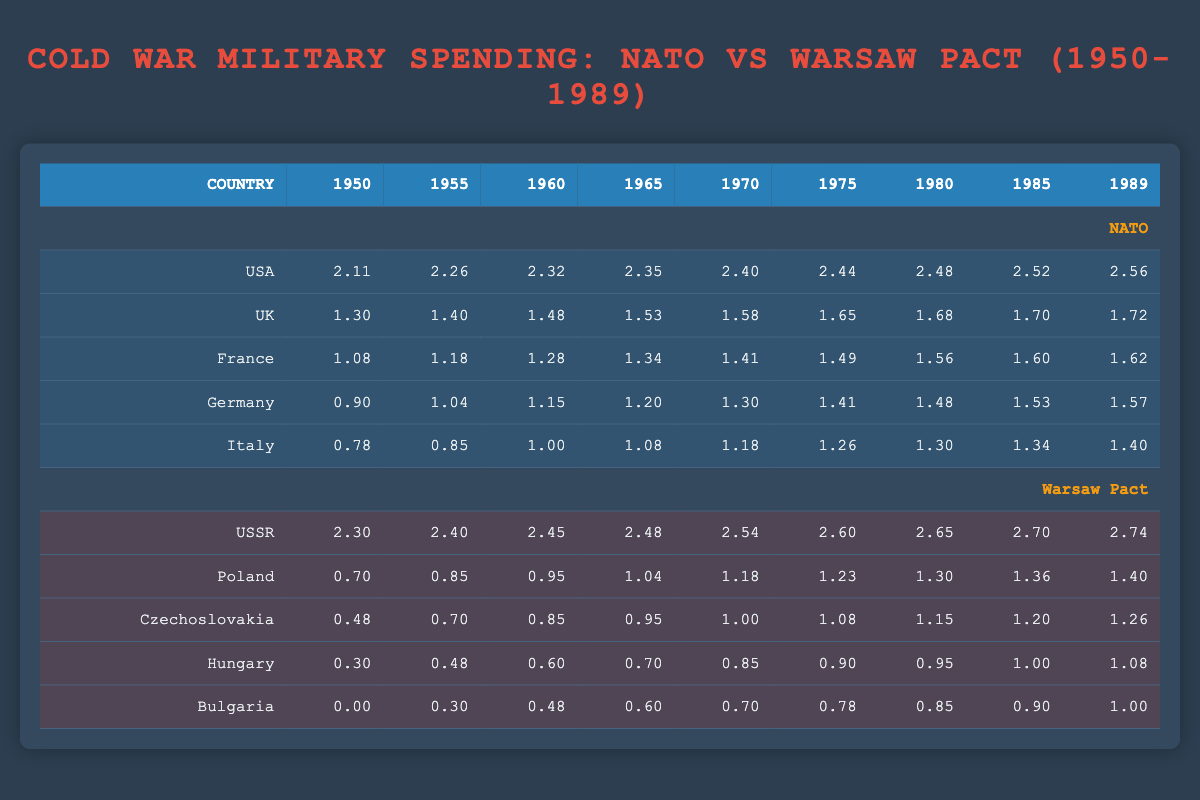What was the military spending of the USA in 1985? The table shows that the military spending of the USA in 1985 is 330.
Answer: 330 What was the total military spending of NATO countries in 1970? The military spending of NATO countries in 1970 includes: USA (250), UK (38), France (26), Germany (20), and Italy (15). Summing these values gives 250 + 38 + 26 + 20 + 15 = 349.
Answer: 349 Did military spending of the USSR increase every year from 1950 to 1989? Looking at the data for the USSR, the spending grew from 200 in 1950 to 550 in 1989, showing an increase each observed year.
Answer: Yes Which NATO country had the lowest military spending in 1965? In 1965, Italy had the lowest military spending among NATO countries, which is 12.
Answer: 12 What was the average military spending of Poland from 1955 to 1989? The spending for Poland from 1955 to 1989 is: 7, 9, 11, 15, 17, 20, 23, 25. The total is 7 + 9 + 11 + 15 + 17 + 20 + 23 + 25 = 127. There are 8 data points, so the average is 127 / 8 = 15.875.
Answer: 15.88 Was the military spending of Hungary greater than that of Czechoslovakia in 1980? In 1980, Hungary's military spending was 9, while Czechoslovakia's was 14, indicating that Hungary's spending was less than Czechoslovakia's.
Answer: No In which year did NATO military spending exceed that of the USSR? Observing the table, NATO military spending only surpassed USSR spending in 1989, when NATO totalled 366 while the USSR was at 550.
Answer: 1989 What is the difference in military spending between the USA and the UK in 1989? In 1989, the USA's military spending was 366, and the UK's was 52. The difference is calculated as 366 - 52 = 314.
Answer: 314 For which year was the military spending of France closest to that of Germany? In 1975, France's spending was 31, and Germany's was 26. The closest values occur in that year, with a difference of only 5.
Answer: 1975 